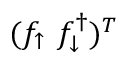Convert formula to latex. <formula><loc_0><loc_0><loc_500><loc_500>( f _ { \uparrow } \ f _ { \downarrow } ^ { \dagger } ) ^ { T }</formula> 